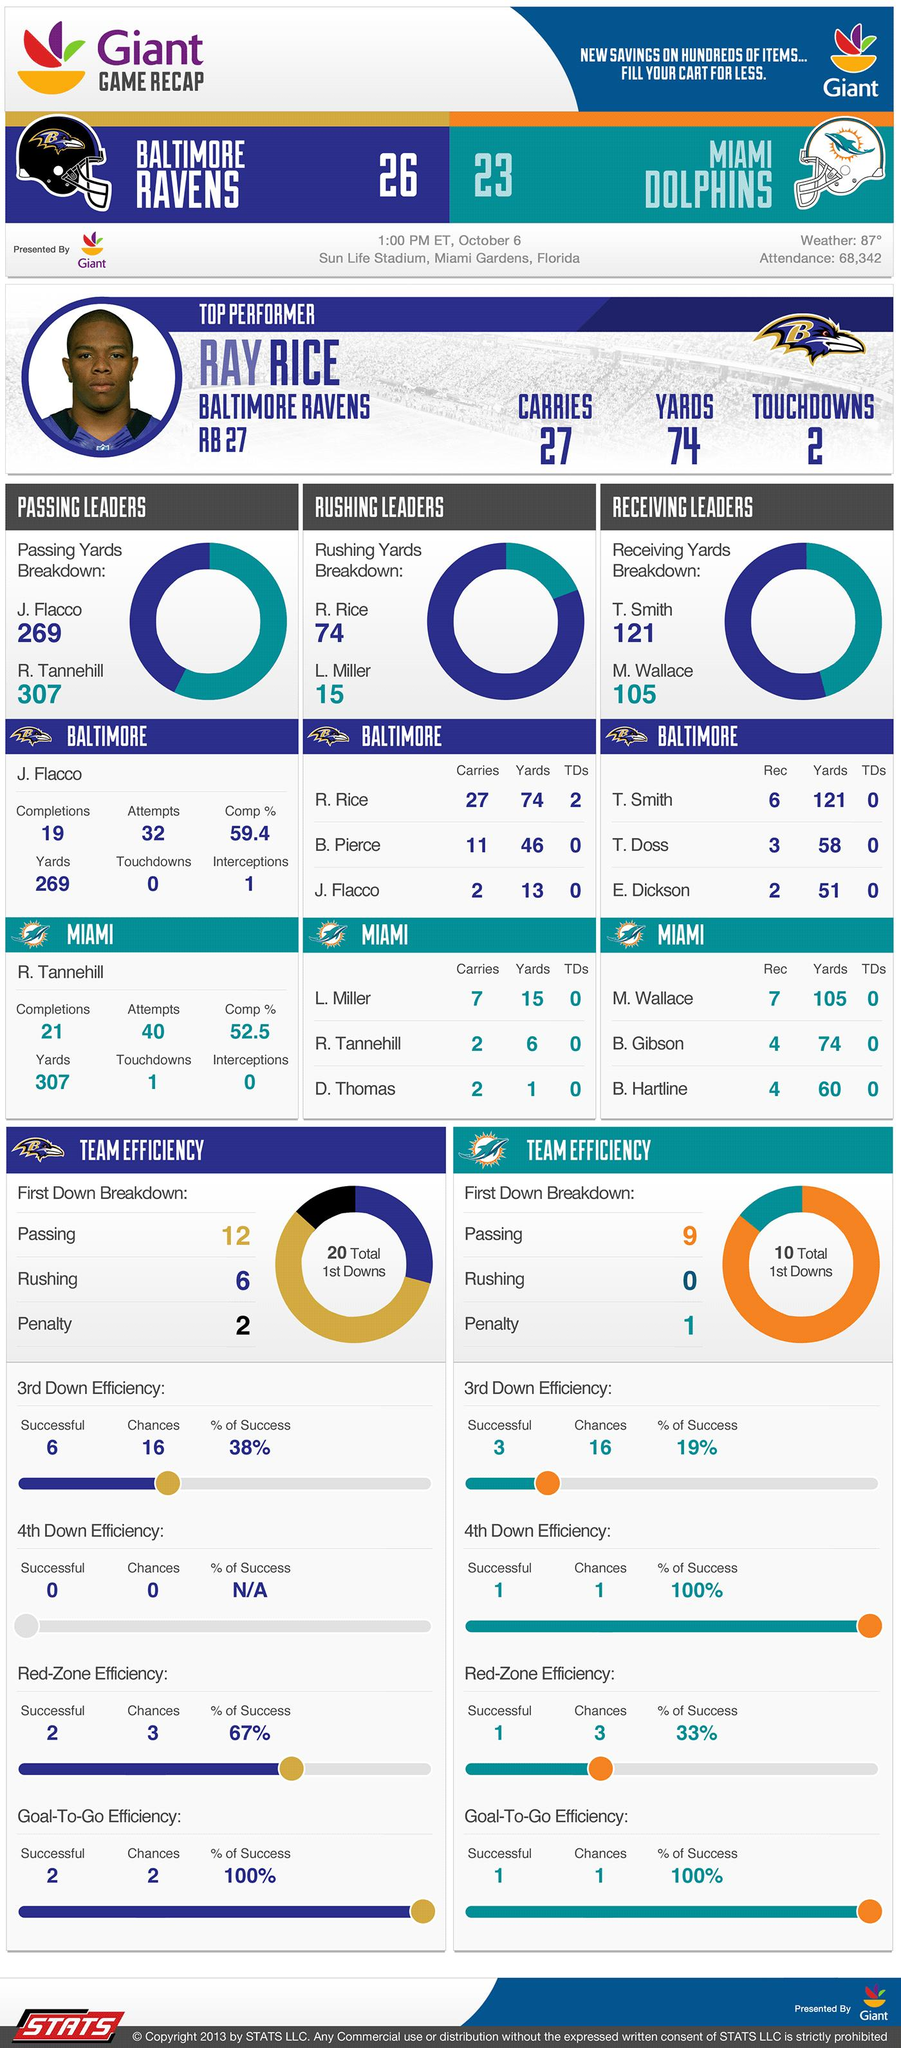List a handful of essential elements in this visual. On October 6, 2013, a total of 68,342 people attended the Baltimore Ravens vs. Miami Dolphins NFL game. The top performer in the Baltimore Ravens vs. Miami Dolphins NFL game on October 6, 2013 was Ray Rice. In the game against the Miami Dolphins on October 6, 2013, Ray Rice scored two touchdowns. 